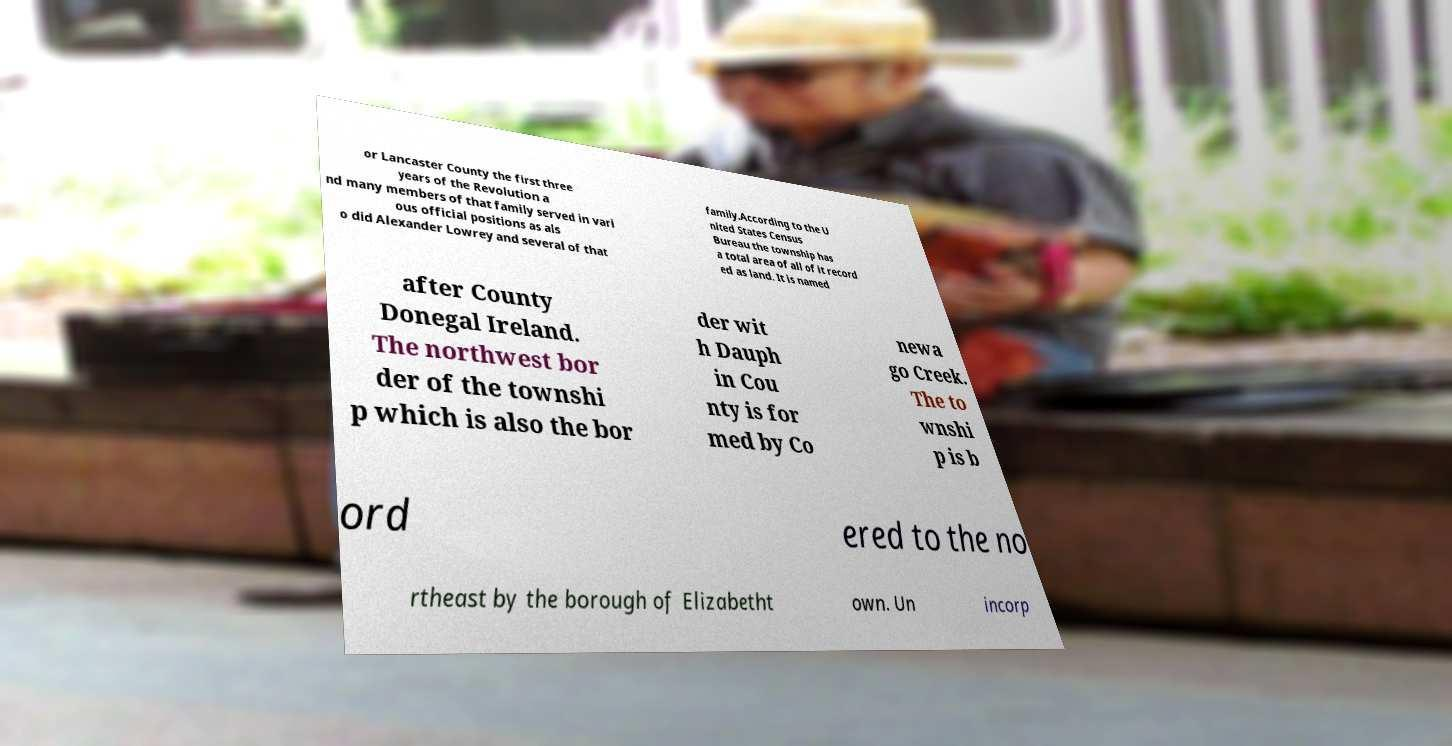Can you accurately transcribe the text from the provided image for me? or Lancaster County the first three years of the Revolution a nd many members of that family served in vari ous official positions as als o did Alexander Lowrey and several of that family.According to the U nited States Census Bureau the township has a total area of all of it record ed as land. It is named after County Donegal Ireland. The northwest bor der of the townshi p which is also the bor der wit h Dauph in Cou nty is for med by Co newa go Creek. The to wnshi p is b ord ered to the no rtheast by the borough of Elizabetht own. Un incorp 